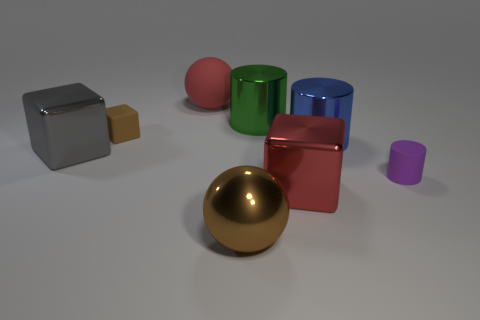Subtract all big metallic cubes. How many cubes are left? 1 Add 2 tiny red blocks. How many objects exist? 10 Subtract all blocks. How many objects are left? 5 Subtract all blue blocks. Subtract all brown cylinders. How many blocks are left? 3 Add 1 tiny brown cubes. How many tiny brown cubes are left? 2 Add 5 big gray things. How many big gray things exist? 6 Subtract 0 green balls. How many objects are left? 8 Subtract all large blue cubes. Subtract all rubber cylinders. How many objects are left? 7 